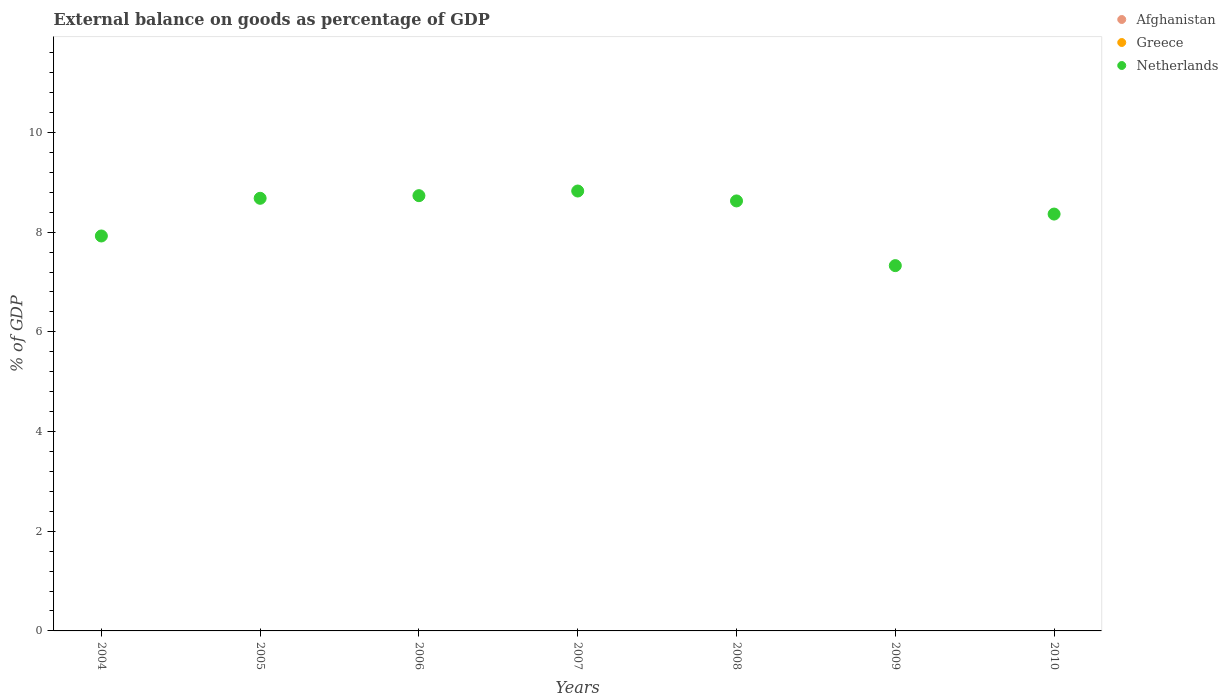What is the external balance on goods as percentage of GDP in Greece in 2008?
Your answer should be compact. 0. Across all years, what is the maximum external balance on goods as percentage of GDP in Netherlands?
Your answer should be very brief. 8.83. Across all years, what is the minimum external balance on goods as percentage of GDP in Afghanistan?
Offer a very short reply. 0. In which year was the external balance on goods as percentage of GDP in Netherlands maximum?
Offer a very short reply. 2007. What is the total external balance on goods as percentage of GDP in Afghanistan in the graph?
Keep it short and to the point. 0. What is the difference between the external balance on goods as percentage of GDP in Netherlands in 2004 and that in 2006?
Provide a succinct answer. -0.81. What is the ratio of the external balance on goods as percentage of GDP in Netherlands in 2004 to that in 2006?
Make the answer very short. 0.91. What is the difference between the highest and the lowest external balance on goods as percentage of GDP in Netherlands?
Provide a succinct answer. 1.5. Does the external balance on goods as percentage of GDP in Afghanistan monotonically increase over the years?
Ensure brevity in your answer.  No. Is the external balance on goods as percentage of GDP in Greece strictly less than the external balance on goods as percentage of GDP in Afghanistan over the years?
Your response must be concise. No. What is the difference between two consecutive major ticks on the Y-axis?
Offer a very short reply. 2. Are the values on the major ticks of Y-axis written in scientific E-notation?
Your answer should be very brief. No. Does the graph contain grids?
Keep it short and to the point. No. How many legend labels are there?
Your answer should be compact. 3. How are the legend labels stacked?
Offer a terse response. Vertical. What is the title of the graph?
Keep it short and to the point. External balance on goods as percentage of GDP. What is the label or title of the X-axis?
Ensure brevity in your answer.  Years. What is the label or title of the Y-axis?
Give a very brief answer. % of GDP. What is the % of GDP in Greece in 2004?
Ensure brevity in your answer.  0. What is the % of GDP of Netherlands in 2004?
Your answer should be very brief. 7.92. What is the % of GDP in Netherlands in 2005?
Give a very brief answer. 8.68. What is the % of GDP of Afghanistan in 2006?
Offer a very short reply. 0. What is the % of GDP in Netherlands in 2006?
Give a very brief answer. 8.73. What is the % of GDP in Netherlands in 2007?
Ensure brevity in your answer.  8.83. What is the % of GDP of Netherlands in 2008?
Keep it short and to the point. 8.63. What is the % of GDP in Greece in 2009?
Offer a terse response. 0. What is the % of GDP of Netherlands in 2009?
Your answer should be very brief. 7.33. What is the % of GDP in Afghanistan in 2010?
Provide a succinct answer. 0. What is the % of GDP of Netherlands in 2010?
Your answer should be compact. 8.36. Across all years, what is the maximum % of GDP in Netherlands?
Your answer should be compact. 8.83. Across all years, what is the minimum % of GDP of Netherlands?
Your answer should be compact. 7.33. What is the total % of GDP of Greece in the graph?
Provide a succinct answer. 0. What is the total % of GDP in Netherlands in the graph?
Your answer should be very brief. 58.48. What is the difference between the % of GDP of Netherlands in 2004 and that in 2005?
Ensure brevity in your answer.  -0.76. What is the difference between the % of GDP in Netherlands in 2004 and that in 2006?
Your answer should be very brief. -0.81. What is the difference between the % of GDP of Netherlands in 2004 and that in 2007?
Keep it short and to the point. -0.9. What is the difference between the % of GDP of Netherlands in 2004 and that in 2008?
Give a very brief answer. -0.7. What is the difference between the % of GDP of Netherlands in 2004 and that in 2009?
Make the answer very short. 0.59. What is the difference between the % of GDP of Netherlands in 2004 and that in 2010?
Make the answer very short. -0.44. What is the difference between the % of GDP of Netherlands in 2005 and that in 2006?
Give a very brief answer. -0.05. What is the difference between the % of GDP of Netherlands in 2005 and that in 2007?
Your answer should be compact. -0.15. What is the difference between the % of GDP of Netherlands in 2005 and that in 2008?
Your answer should be compact. 0.05. What is the difference between the % of GDP in Netherlands in 2005 and that in 2009?
Keep it short and to the point. 1.35. What is the difference between the % of GDP of Netherlands in 2005 and that in 2010?
Offer a terse response. 0.32. What is the difference between the % of GDP in Netherlands in 2006 and that in 2007?
Offer a terse response. -0.09. What is the difference between the % of GDP in Netherlands in 2006 and that in 2008?
Make the answer very short. 0.11. What is the difference between the % of GDP of Netherlands in 2006 and that in 2009?
Make the answer very short. 1.4. What is the difference between the % of GDP in Netherlands in 2006 and that in 2010?
Provide a succinct answer. 0.37. What is the difference between the % of GDP in Netherlands in 2007 and that in 2008?
Your response must be concise. 0.2. What is the difference between the % of GDP in Netherlands in 2007 and that in 2009?
Provide a succinct answer. 1.5. What is the difference between the % of GDP in Netherlands in 2007 and that in 2010?
Give a very brief answer. 0.46. What is the difference between the % of GDP in Netherlands in 2008 and that in 2009?
Your answer should be compact. 1.3. What is the difference between the % of GDP of Netherlands in 2008 and that in 2010?
Make the answer very short. 0.26. What is the difference between the % of GDP in Netherlands in 2009 and that in 2010?
Offer a terse response. -1.03. What is the average % of GDP of Afghanistan per year?
Provide a succinct answer. 0. What is the average % of GDP in Netherlands per year?
Your answer should be compact. 8.35. What is the ratio of the % of GDP in Netherlands in 2004 to that in 2005?
Keep it short and to the point. 0.91. What is the ratio of the % of GDP of Netherlands in 2004 to that in 2006?
Your response must be concise. 0.91. What is the ratio of the % of GDP of Netherlands in 2004 to that in 2007?
Offer a very short reply. 0.9. What is the ratio of the % of GDP in Netherlands in 2004 to that in 2008?
Provide a short and direct response. 0.92. What is the ratio of the % of GDP in Netherlands in 2004 to that in 2009?
Your answer should be very brief. 1.08. What is the ratio of the % of GDP in Netherlands in 2004 to that in 2010?
Your answer should be very brief. 0.95. What is the ratio of the % of GDP in Netherlands in 2005 to that in 2007?
Make the answer very short. 0.98. What is the ratio of the % of GDP in Netherlands in 2005 to that in 2008?
Give a very brief answer. 1.01. What is the ratio of the % of GDP in Netherlands in 2005 to that in 2009?
Ensure brevity in your answer.  1.18. What is the ratio of the % of GDP in Netherlands in 2005 to that in 2010?
Give a very brief answer. 1.04. What is the ratio of the % of GDP in Netherlands in 2006 to that in 2008?
Offer a very short reply. 1.01. What is the ratio of the % of GDP of Netherlands in 2006 to that in 2009?
Make the answer very short. 1.19. What is the ratio of the % of GDP of Netherlands in 2006 to that in 2010?
Ensure brevity in your answer.  1.04. What is the ratio of the % of GDP of Netherlands in 2007 to that in 2009?
Keep it short and to the point. 1.2. What is the ratio of the % of GDP of Netherlands in 2007 to that in 2010?
Your response must be concise. 1.06. What is the ratio of the % of GDP of Netherlands in 2008 to that in 2009?
Your response must be concise. 1.18. What is the ratio of the % of GDP in Netherlands in 2008 to that in 2010?
Offer a very short reply. 1.03. What is the ratio of the % of GDP in Netherlands in 2009 to that in 2010?
Give a very brief answer. 0.88. What is the difference between the highest and the second highest % of GDP of Netherlands?
Provide a short and direct response. 0.09. What is the difference between the highest and the lowest % of GDP of Netherlands?
Keep it short and to the point. 1.5. 